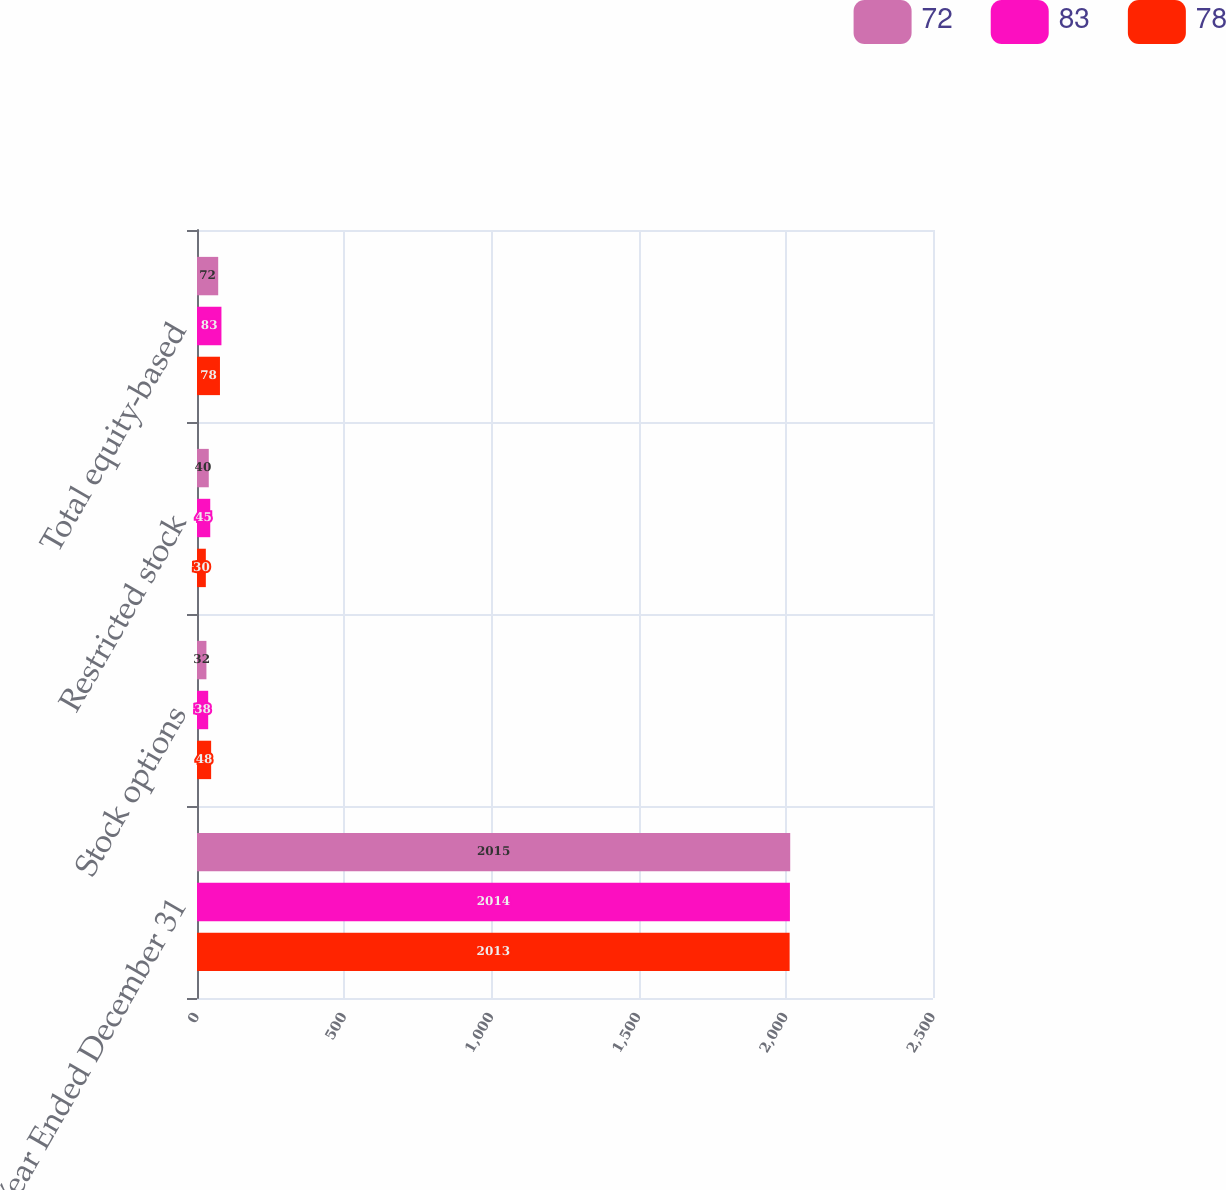Convert chart. <chart><loc_0><loc_0><loc_500><loc_500><stacked_bar_chart><ecel><fcel>Year Ended December 31<fcel>Stock options<fcel>Restricted stock<fcel>Total equity-based<nl><fcel>72<fcel>2015<fcel>32<fcel>40<fcel>72<nl><fcel>83<fcel>2014<fcel>38<fcel>45<fcel>83<nl><fcel>78<fcel>2013<fcel>48<fcel>30<fcel>78<nl></chart> 